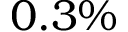Convert formula to latex. <formula><loc_0><loc_0><loc_500><loc_500>0 . 3 \%</formula> 